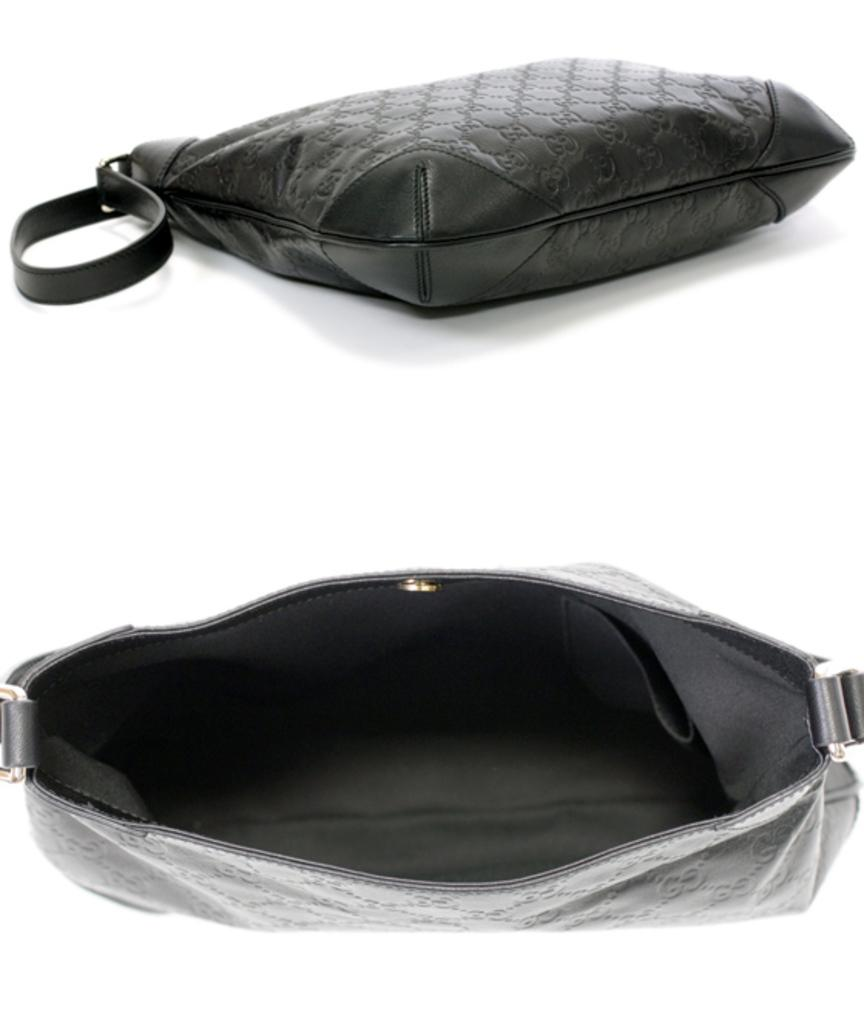How many bags can be seen in the image? There are two black-colored bags in the image. What is the state of one of the bags? One of the bags is opened. Can you see your dad's toes in the image? There is no reference to feet or toes in the image, so it is not possible to see your dad's toes. 